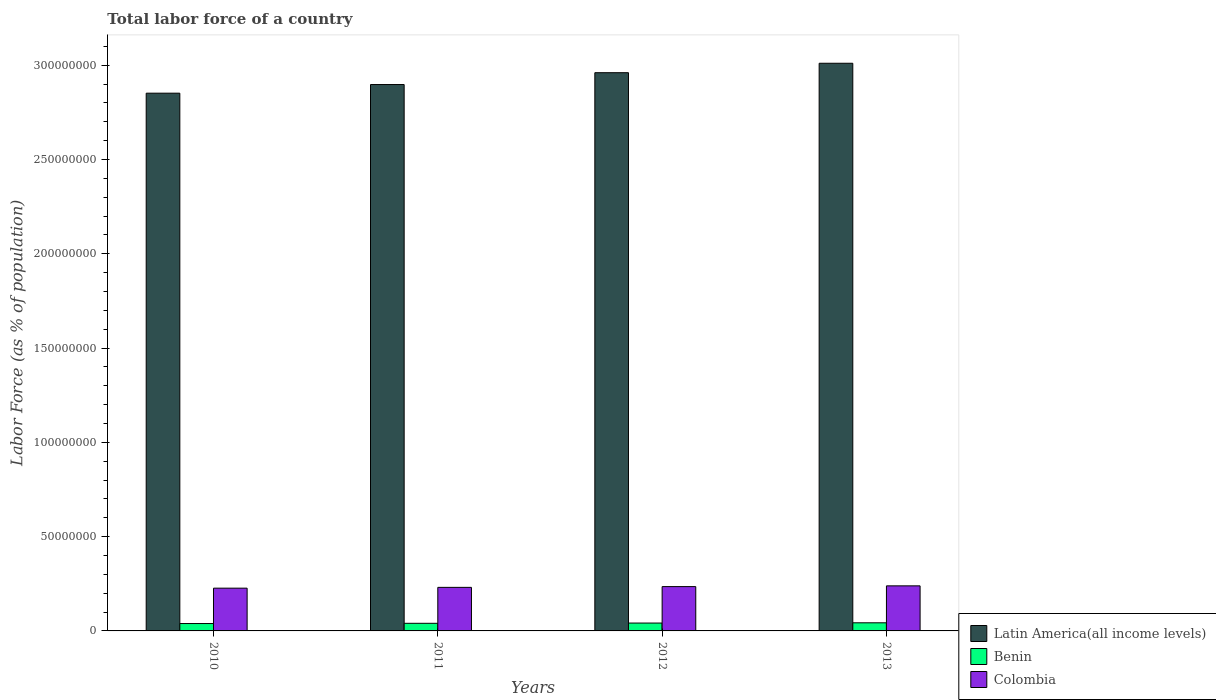Are the number of bars on each tick of the X-axis equal?
Your answer should be compact. Yes. How many bars are there on the 3rd tick from the right?
Provide a short and direct response. 3. What is the label of the 2nd group of bars from the left?
Make the answer very short. 2011. What is the percentage of labor force in Colombia in 2013?
Ensure brevity in your answer.  2.39e+07. Across all years, what is the maximum percentage of labor force in Latin America(all income levels)?
Ensure brevity in your answer.  3.01e+08. Across all years, what is the minimum percentage of labor force in Latin America(all income levels)?
Your response must be concise. 2.85e+08. What is the total percentage of labor force in Colombia in the graph?
Your answer should be very brief. 9.32e+07. What is the difference between the percentage of labor force in Benin in 2011 and that in 2012?
Give a very brief answer. -1.28e+05. What is the difference between the percentage of labor force in Colombia in 2011 and the percentage of labor force in Benin in 2010?
Your answer should be compact. 1.92e+07. What is the average percentage of labor force in Colombia per year?
Your response must be concise. 2.33e+07. In the year 2013, what is the difference between the percentage of labor force in Benin and percentage of labor force in Latin America(all income levels)?
Your answer should be compact. -2.97e+08. What is the ratio of the percentage of labor force in Colombia in 2010 to that in 2013?
Your answer should be very brief. 0.95. Is the percentage of labor force in Benin in 2010 less than that in 2013?
Make the answer very short. Yes. Is the difference between the percentage of labor force in Benin in 2011 and 2013 greater than the difference between the percentage of labor force in Latin America(all income levels) in 2011 and 2013?
Make the answer very short. Yes. What is the difference between the highest and the second highest percentage of labor force in Benin?
Give a very brief answer. 1.38e+05. What is the difference between the highest and the lowest percentage of labor force in Colombia?
Provide a succinct answer. 1.22e+06. What does the 2nd bar from the left in 2012 represents?
Offer a very short reply. Benin. What does the 2nd bar from the right in 2013 represents?
Offer a terse response. Benin. How many bars are there?
Keep it short and to the point. 12. Are all the bars in the graph horizontal?
Make the answer very short. No. How many years are there in the graph?
Your answer should be very brief. 4. What is the difference between two consecutive major ticks on the Y-axis?
Give a very brief answer. 5.00e+07. Where does the legend appear in the graph?
Your answer should be very brief. Bottom right. How many legend labels are there?
Your response must be concise. 3. How are the legend labels stacked?
Your answer should be compact. Vertical. What is the title of the graph?
Keep it short and to the point. Total labor force of a country. What is the label or title of the Y-axis?
Provide a succinct answer. Labor Force (as % of population). What is the Labor Force (as % of population) in Latin America(all income levels) in 2010?
Offer a terse response. 2.85e+08. What is the Labor Force (as % of population) of Benin in 2010?
Keep it short and to the point. 3.92e+06. What is the Labor Force (as % of population) of Colombia in 2010?
Provide a short and direct response. 2.27e+07. What is the Labor Force (as % of population) of Latin America(all income levels) in 2011?
Give a very brief answer. 2.90e+08. What is the Labor Force (as % of population) in Benin in 2011?
Ensure brevity in your answer.  4.04e+06. What is the Labor Force (as % of population) in Colombia in 2011?
Ensure brevity in your answer.  2.31e+07. What is the Labor Force (as % of population) of Latin America(all income levels) in 2012?
Give a very brief answer. 2.96e+08. What is the Labor Force (as % of population) in Benin in 2012?
Keep it short and to the point. 4.17e+06. What is the Labor Force (as % of population) of Colombia in 2012?
Your answer should be very brief. 2.35e+07. What is the Labor Force (as % of population) in Latin America(all income levels) in 2013?
Your answer should be compact. 3.01e+08. What is the Labor Force (as % of population) of Benin in 2013?
Offer a very short reply. 4.31e+06. What is the Labor Force (as % of population) of Colombia in 2013?
Provide a short and direct response. 2.39e+07. Across all years, what is the maximum Labor Force (as % of population) of Latin America(all income levels)?
Provide a short and direct response. 3.01e+08. Across all years, what is the maximum Labor Force (as % of population) of Benin?
Make the answer very short. 4.31e+06. Across all years, what is the maximum Labor Force (as % of population) in Colombia?
Give a very brief answer. 2.39e+07. Across all years, what is the minimum Labor Force (as % of population) in Latin America(all income levels)?
Provide a succinct answer. 2.85e+08. Across all years, what is the minimum Labor Force (as % of population) of Benin?
Offer a very short reply. 3.92e+06. Across all years, what is the minimum Labor Force (as % of population) in Colombia?
Offer a terse response. 2.27e+07. What is the total Labor Force (as % of population) in Latin America(all income levels) in the graph?
Offer a very short reply. 1.17e+09. What is the total Labor Force (as % of population) of Benin in the graph?
Give a very brief answer. 1.64e+07. What is the total Labor Force (as % of population) in Colombia in the graph?
Your response must be concise. 9.32e+07. What is the difference between the Labor Force (as % of population) of Latin America(all income levels) in 2010 and that in 2011?
Your response must be concise. -4.59e+06. What is the difference between the Labor Force (as % of population) in Benin in 2010 and that in 2011?
Your answer should be compact. -1.24e+05. What is the difference between the Labor Force (as % of population) in Colombia in 2010 and that in 2011?
Your answer should be very brief. -4.23e+05. What is the difference between the Labor Force (as % of population) in Latin America(all income levels) in 2010 and that in 2012?
Ensure brevity in your answer.  -1.09e+07. What is the difference between the Labor Force (as % of population) of Benin in 2010 and that in 2012?
Provide a short and direct response. -2.52e+05. What is the difference between the Labor Force (as % of population) of Colombia in 2010 and that in 2012?
Keep it short and to the point. -8.28e+05. What is the difference between the Labor Force (as % of population) in Latin America(all income levels) in 2010 and that in 2013?
Ensure brevity in your answer.  -1.59e+07. What is the difference between the Labor Force (as % of population) in Benin in 2010 and that in 2013?
Give a very brief answer. -3.91e+05. What is the difference between the Labor Force (as % of population) in Colombia in 2010 and that in 2013?
Provide a short and direct response. -1.22e+06. What is the difference between the Labor Force (as % of population) of Latin America(all income levels) in 2011 and that in 2012?
Keep it short and to the point. -6.27e+06. What is the difference between the Labor Force (as % of population) of Benin in 2011 and that in 2012?
Offer a terse response. -1.28e+05. What is the difference between the Labor Force (as % of population) in Colombia in 2011 and that in 2012?
Your response must be concise. -4.05e+05. What is the difference between the Labor Force (as % of population) of Latin America(all income levels) in 2011 and that in 2013?
Provide a succinct answer. -1.13e+07. What is the difference between the Labor Force (as % of population) of Benin in 2011 and that in 2013?
Provide a short and direct response. -2.66e+05. What is the difference between the Labor Force (as % of population) in Colombia in 2011 and that in 2013?
Offer a very short reply. -7.97e+05. What is the difference between the Labor Force (as % of population) in Latin America(all income levels) in 2012 and that in 2013?
Provide a succinct answer. -5.01e+06. What is the difference between the Labor Force (as % of population) in Benin in 2012 and that in 2013?
Make the answer very short. -1.38e+05. What is the difference between the Labor Force (as % of population) of Colombia in 2012 and that in 2013?
Provide a short and direct response. -3.92e+05. What is the difference between the Labor Force (as % of population) of Latin America(all income levels) in 2010 and the Labor Force (as % of population) of Benin in 2011?
Offer a terse response. 2.81e+08. What is the difference between the Labor Force (as % of population) of Latin America(all income levels) in 2010 and the Labor Force (as % of population) of Colombia in 2011?
Your answer should be compact. 2.62e+08. What is the difference between the Labor Force (as % of population) of Benin in 2010 and the Labor Force (as % of population) of Colombia in 2011?
Keep it short and to the point. -1.92e+07. What is the difference between the Labor Force (as % of population) in Latin America(all income levels) in 2010 and the Labor Force (as % of population) in Benin in 2012?
Your response must be concise. 2.81e+08. What is the difference between the Labor Force (as % of population) in Latin America(all income levels) in 2010 and the Labor Force (as % of population) in Colombia in 2012?
Your answer should be very brief. 2.62e+08. What is the difference between the Labor Force (as % of population) of Benin in 2010 and the Labor Force (as % of population) of Colombia in 2012?
Ensure brevity in your answer.  -1.96e+07. What is the difference between the Labor Force (as % of population) of Latin America(all income levels) in 2010 and the Labor Force (as % of population) of Benin in 2013?
Give a very brief answer. 2.81e+08. What is the difference between the Labor Force (as % of population) in Latin America(all income levels) in 2010 and the Labor Force (as % of population) in Colombia in 2013?
Offer a very short reply. 2.61e+08. What is the difference between the Labor Force (as % of population) in Benin in 2010 and the Labor Force (as % of population) in Colombia in 2013?
Offer a terse response. -2.00e+07. What is the difference between the Labor Force (as % of population) of Latin America(all income levels) in 2011 and the Labor Force (as % of population) of Benin in 2012?
Offer a very short reply. 2.86e+08. What is the difference between the Labor Force (as % of population) in Latin America(all income levels) in 2011 and the Labor Force (as % of population) in Colombia in 2012?
Keep it short and to the point. 2.66e+08. What is the difference between the Labor Force (as % of population) in Benin in 2011 and the Labor Force (as % of population) in Colombia in 2012?
Ensure brevity in your answer.  -1.95e+07. What is the difference between the Labor Force (as % of population) of Latin America(all income levels) in 2011 and the Labor Force (as % of population) of Benin in 2013?
Give a very brief answer. 2.85e+08. What is the difference between the Labor Force (as % of population) of Latin America(all income levels) in 2011 and the Labor Force (as % of population) of Colombia in 2013?
Your answer should be compact. 2.66e+08. What is the difference between the Labor Force (as % of population) of Benin in 2011 and the Labor Force (as % of population) of Colombia in 2013?
Offer a very short reply. -1.99e+07. What is the difference between the Labor Force (as % of population) in Latin America(all income levels) in 2012 and the Labor Force (as % of population) in Benin in 2013?
Your answer should be very brief. 2.92e+08. What is the difference between the Labor Force (as % of population) of Latin America(all income levels) in 2012 and the Labor Force (as % of population) of Colombia in 2013?
Your response must be concise. 2.72e+08. What is the difference between the Labor Force (as % of population) of Benin in 2012 and the Labor Force (as % of population) of Colombia in 2013?
Provide a short and direct response. -1.97e+07. What is the average Labor Force (as % of population) in Latin America(all income levels) per year?
Offer a terse response. 2.93e+08. What is the average Labor Force (as % of population) in Benin per year?
Your answer should be compact. 4.11e+06. What is the average Labor Force (as % of population) of Colombia per year?
Your response must be concise. 2.33e+07. In the year 2010, what is the difference between the Labor Force (as % of population) in Latin America(all income levels) and Labor Force (as % of population) in Benin?
Ensure brevity in your answer.  2.81e+08. In the year 2010, what is the difference between the Labor Force (as % of population) of Latin America(all income levels) and Labor Force (as % of population) of Colombia?
Provide a short and direct response. 2.63e+08. In the year 2010, what is the difference between the Labor Force (as % of population) of Benin and Labor Force (as % of population) of Colombia?
Offer a very short reply. -1.88e+07. In the year 2011, what is the difference between the Labor Force (as % of population) in Latin America(all income levels) and Labor Force (as % of population) in Benin?
Offer a terse response. 2.86e+08. In the year 2011, what is the difference between the Labor Force (as % of population) of Latin America(all income levels) and Labor Force (as % of population) of Colombia?
Ensure brevity in your answer.  2.67e+08. In the year 2011, what is the difference between the Labor Force (as % of population) in Benin and Labor Force (as % of population) in Colombia?
Provide a succinct answer. -1.91e+07. In the year 2012, what is the difference between the Labor Force (as % of population) in Latin America(all income levels) and Labor Force (as % of population) in Benin?
Your response must be concise. 2.92e+08. In the year 2012, what is the difference between the Labor Force (as % of population) of Latin America(all income levels) and Labor Force (as % of population) of Colombia?
Offer a very short reply. 2.73e+08. In the year 2012, what is the difference between the Labor Force (as % of population) of Benin and Labor Force (as % of population) of Colombia?
Provide a succinct answer. -1.93e+07. In the year 2013, what is the difference between the Labor Force (as % of population) in Latin America(all income levels) and Labor Force (as % of population) in Benin?
Make the answer very short. 2.97e+08. In the year 2013, what is the difference between the Labor Force (as % of population) of Latin America(all income levels) and Labor Force (as % of population) of Colombia?
Provide a succinct answer. 2.77e+08. In the year 2013, what is the difference between the Labor Force (as % of population) of Benin and Labor Force (as % of population) of Colombia?
Ensure brevity in your answer.  -1.96e+07. What is the ratio of the Labor Force (as % of population) of Latin America(all income levels) in 2010 to that in 2011?
Provide a succinct answer. 0.98. What is the ratio of the Labor Force (as % of population) of Benin in 2010 to that in 2011?
Your answer should be very brief. 0.97. What is the ratio of the Labor Force (as % of population) of Colombia in 2010 to that in 2011?
Your answer should be very brief. 0.98. What is the ratio of the Labor Force (as % of population) in Latin America(all income levels) in 2010 to that in 2012?
Ensure brevity in your answer.  0.96. What is the ratio of the Labor Force (as % of population) of Benin in 2010 to that in 2012?
Your response must be concise. 0.94. What is the ratio of the Labor Force (as % of population) of Colombia in 2010 to that in 2012?
Ensure brevity in your answer.  0.96. What is the ratio of the Labor Force (as % of population) in Latin America(all income levels) in 2010 to that in 2013?
Ensure brevity in your answer.  0.95. What is the ratio of the Labor Force (as % of population) in Benin in 2010 to that in 2013?
Give a very brief answer. 0.91. What is the ratio of the Labor Force (as % of population) of Colombia in 2010 to that in 2013?
Provide a succinct answer. 0.95. What is the ratio of the Labor Force (as % of population) of Latin America(all income levels) in 2011 to that in 2012?
Provide a succinct answer. 0.98. What is the ratio of the Labor Force (as % of population) of Benin in 2011 to that in 2012?
Provide a short and direct response. 0.97. What is the ratio of the Labor Force (as % of population) in Colombia in 2011 to that in 2012?
Offer a very short reply. 0.98. What is the ratio of the Labor Force (as % of population) of Latin America(all income levels) in 2011 to that in 2013?
Your answer should be very brief. 0.96. What is the ratio of the Labor Force (as % of population) of Benin in 2011 to that in 2013?
Make the answer very short. 0.94. What is the ratio of the Labor Force (as % of population) in Colombia in 2011 to that in 2013?
Keep it short and to the point. 0.97. What is the ratio of the Labor Force (as % of population) of Latin America(all income levels) in 2012 to that in 2013?
Keep it short and to the point. 0.98. What is the ratio of the Labor Force (as % of population) of Benin in 2012 to that in 2013?
Make the answer very short. 0.97. What is the ratio of the Labor Force (as % of population) in Colombia in 2012 to that in 2013?
Make the answer very short. 0.98. What is the difference between the highest and the second highest Labor Force (as % of population) of Latin America(all income levels)?
Provide a short and direct response. 5.01e+06. What is the difference between the highest and the second highest Labor Force (as % of population) of Benin?
Your answer should be very brief. 1.38e+05. What is the difference between the highest and the second highest Labor Force (as % of population) of Colombia?
Provide a succinct answer. 3.92e+05. What is the difference between the highest and the lowest Labor Force (as % of population) in Latin America(all income levels)?
Your response must be concise. 1.59e+07. What is the difference between the highest and the lowest Labor Force (as % of population) in Benin?
Offer a very short reply. 3.91e+05. What is the difference between the highest and the lowest Labor Force (as % of population) in Colombia?
Offer a terse response. 1.22e+06. 